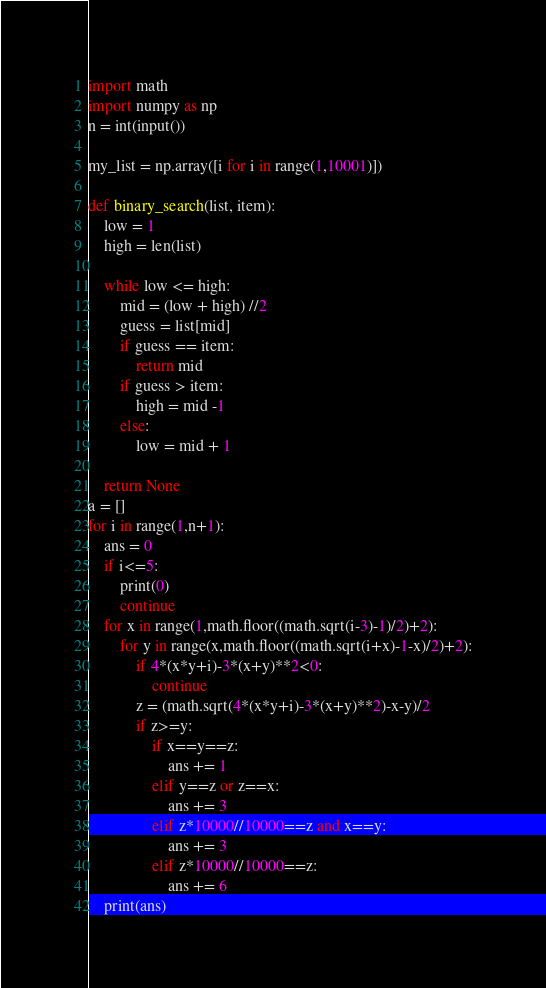Convert code to text. <code><loc_0><loc_0><loc_500><loc_500><_Python_>import math
import numpy as np
n = int(input())

my_list = np.array([i for i in range(1,10001)])

def binary_search(list, item):
    low = 1
    high = len(list)

    while low <= high:
        mid = (low + high) //2
        guess = list[mid]
        if guess == item:
            return mid
        if guess > item:
            high = mid -1
        else:
            low = mid + 1

    return None
a = []
for i in range(1,n+1):
    ans = 0
    if i<=5:
        print(0)
        continue
    for x in range(1,math.floor((math.sqrt(i-3)-1)/2)+2):
        for y in range(x,math.floor((math.sqrt(i+x)-1-x)/2)+2):
            if 4*(x*y+i)-3*(x+y)**2<0:
                continue
            z = (math.sqrt(4*(x*y+i)-3*(x+y)**2)-x-y)/2
            if z>=y:
                if x==y==z:
                    ans += 1
                elif y==z or z==x:
                    ans += 3
                elif z*10000//10000==z and x==y:
                    ans += 3
                elif z*10000//10000==z:
                    ans += 6
    print(ans)
</code> 